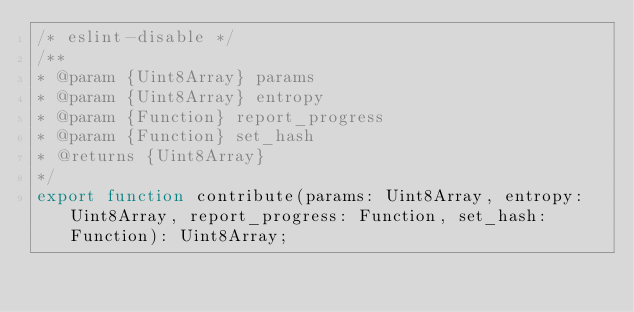Convert code to text. <code><loc_0><loc_0><loc_500><loc_500><_TypeScript_>/* eslint-disable */
/**
* @param {Uint8Array} params 
* @param {Uint8Array} entropy 
* @param {Function} report_progress 
* @param {Function} set_hash 
* @returns {Uint8Array} 
*/
export function contribute(params: Uint8Array, entropy: Uint8Array, report_progress: Function, set_hash: Function): Uint8Array;
</code> 